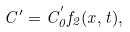Convert formula to latex. <formula><loc_0><loc_0><loc_500><loc_500>C ^ { \prime } = C _ { 0 } ^ { ^ { \prime } } f _ { 2 } ( x , t ) ,</formula> 